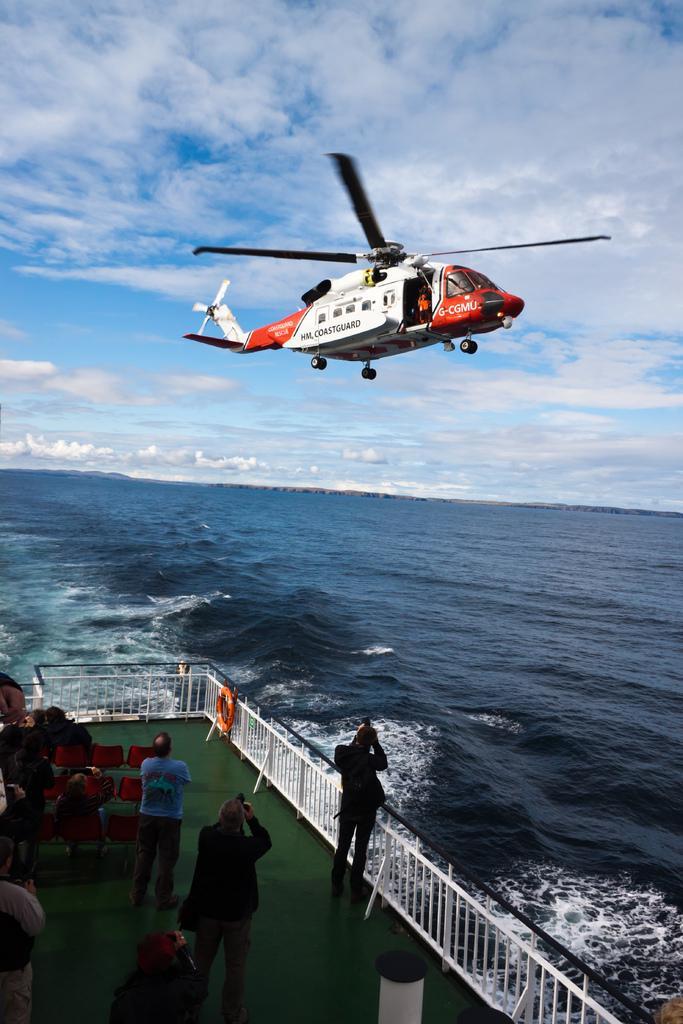How would you summarize this image in a sentence or two? In this image I can see a white and red colour helicopter in the air. In the front I can see few red colour chairs, railing, an orange colour tube and I can also see few people are standing in the front. In the background I can see water, clouds and the sky. 